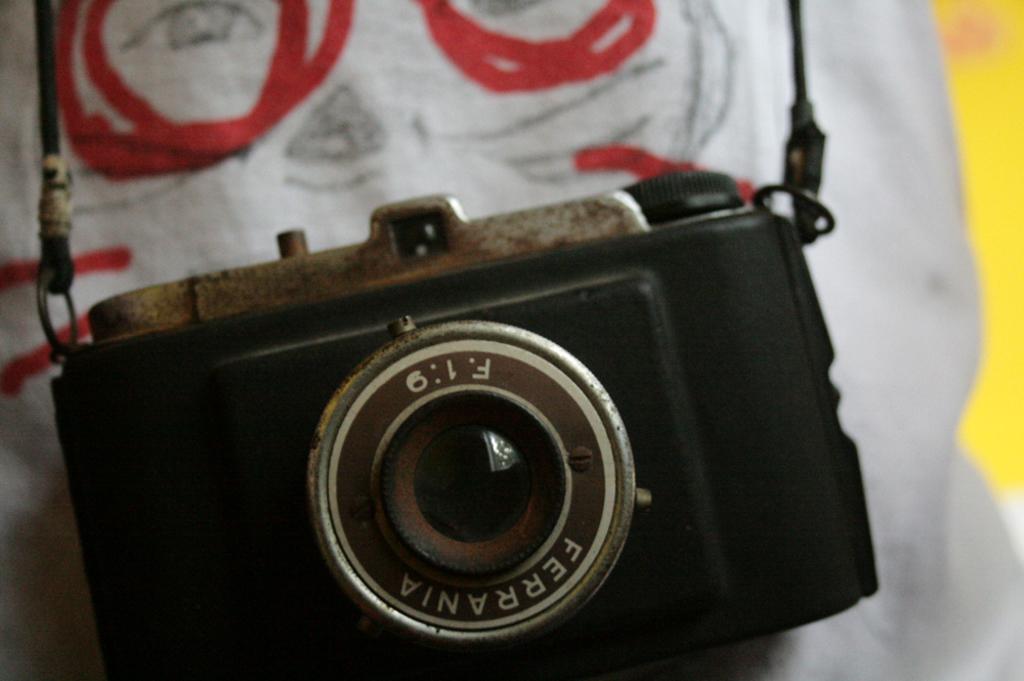In one or two sentences, can you explain what this image depicts? In this image I can see the camera on the white color surface and the camera is in black color. 